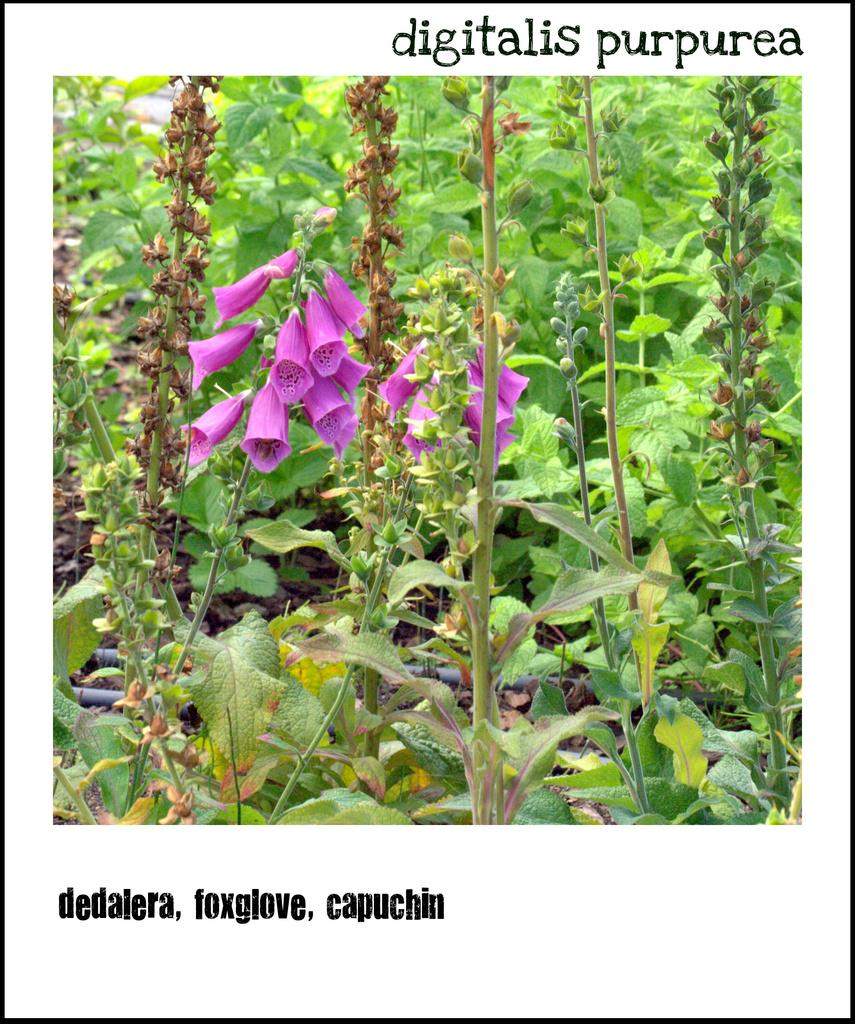What is the main subject of the poster in the image? The poster contains a picture of flowers and plants. What else can be found on the poster besides the image? There is text on the poster. What type of underwear is visible in the image? There is no underwear present in the image. Can you describe the texture of the flowers and plants in the image? The image is not detailed enough to describe the texture of the flowers and plants. 